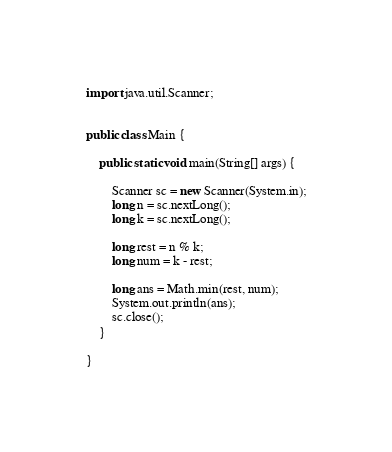<code> <loc_0><loc_0><loc_500><loc_500><_Java_>import java.util.Scanner;

 
public class Main {
 
	public static void main(String[] args) {
		
		Scanner sc = new Scanner(System.in);
		long n = sc.nextLong();
		long k = sc.nextLong();
		
		long rest = n % k;
		long num = k - rest;

		long ans = Math.min(rest, num); 
		System.out.println(ans);
		sc.close();
	}
	
}</code> 